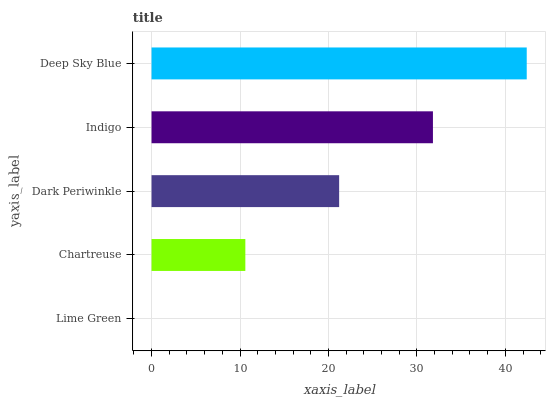Is Lime Green the minimum?
Answer yes or no. Yes. Is Deep Sky Blue the maximum?
Answer yes or no. Yes. Is Chartreuse the minimum?
Answer yes or no. No. Is Chartreuse the maximum?
Answer yes or no. No. Is Chartreuse greater than Lime Green?
Answer yes or no. Yes. Is Lime Green less than Chartreuse?
Answer yes or no. Yes. Is Lime Green greater than Chartreuse?
Answer yes or no. No. Is Chartreuse less than Lime Green?
Answer yes or no. No. Is Dark Periwinkle the high median?
Answer yes or no. Yes. Is Dark Periwinkle the low median?
Answer yes or no. Yes. Is Deep Sky Blue the high median?
Answer yes or no. No. Is Chartreuse the low median?
Answer yes or no. No. 